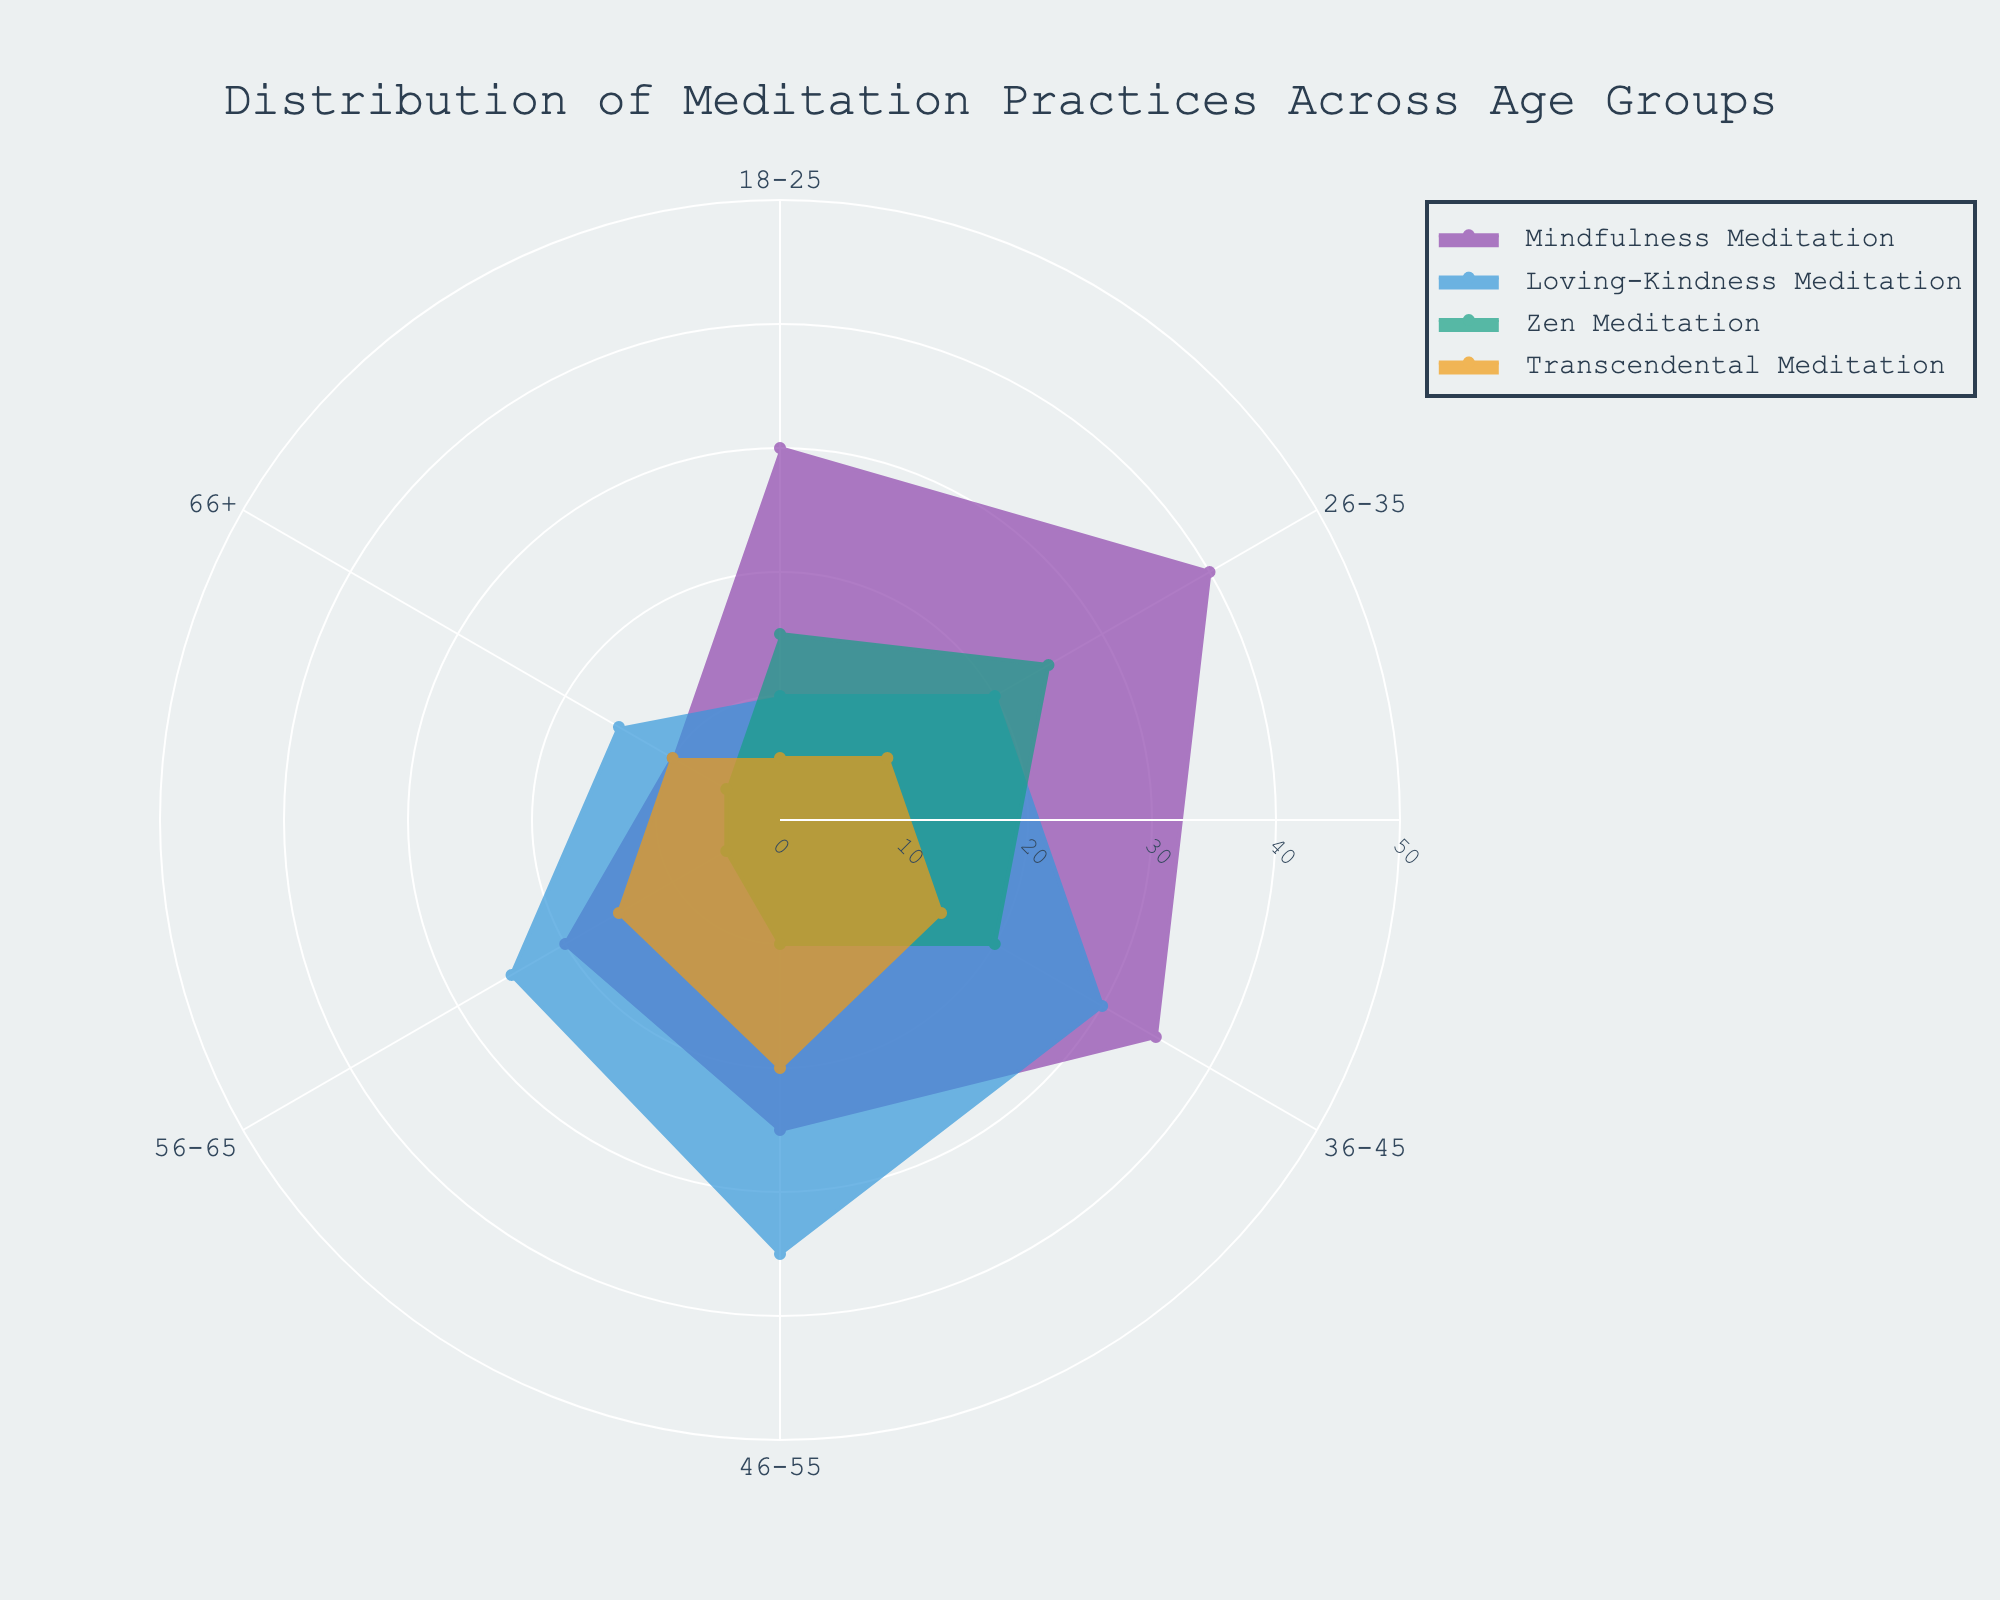What is the title of the chart? The title is displayed at the top of the polar area chart and provides an overview of what the chart represents.
Answer: Distribution of Meditation Practices Across Age Groups Which meditation practice is most prevalent among the 26-35 age group? Look at the segment labeled "26-35" and identify which practice has the longest radius.
Answer: Mindfulness Meditation In which age group is Loving-Kindness Meditation the highest? Examine the segments for Loving-Kindness Meditation across all age groups and identify the one with the largest radius.
Answer: 46-55 What is the combined total of Zen Meditation for the 18-25 and 36-45 age groups? Add the Zen Meditation values for the 18-25 and 36-45 age groups from the corresponding segments.
Answer: 35 How does the percentage of Mindfulness Meditation in the 66+ age group compare to the 18-25 age group? Compare the radius lengths of Mindfulness Meditation for the 66+ vs. 18-25 segments. Calculate the relative difference.
Answer: The 18-25 age group has 30, while the 66+ age group has 10. Mindfulness Meditation is three times higher in the 18-25 age group Which age group practices Transcendental Meditation the least? Observe the segments for Transcendental Meditation and identify the one with the shortest radius.
Answer: 66+ In the 46-55 age group, how does the number of Mindfulness Meditation practitioners compare to Zen Meditation practitioners? Compare the radius lengths for Mindfulness Meditation and Zen Meditation within the 46-55 segment.
Answer: Mindfulness Meditation is 25, Zen Meditation is 10 What is the average number of Loving-Kindness Meditation practitioners across all age groups? Add the values for Loving-Kindness Meditation for each age group and divide by the number of age groups.
Answer: (10+20+30+35+25+15)/6 = 22.5 Which meditation practice has the most consistent participation across all age groups? Observe the shapes and fullness of each color segment for the different meditation types and determine which one has the least variation.
Answer: Transcendental Meditation How many more people practice Zen Meditation in the 26-35 age group compared to the 56-65 age group? Subtract the Zen Meditation value of the 56-65 age group from that of the 26-35 age group.
Answer: 20 